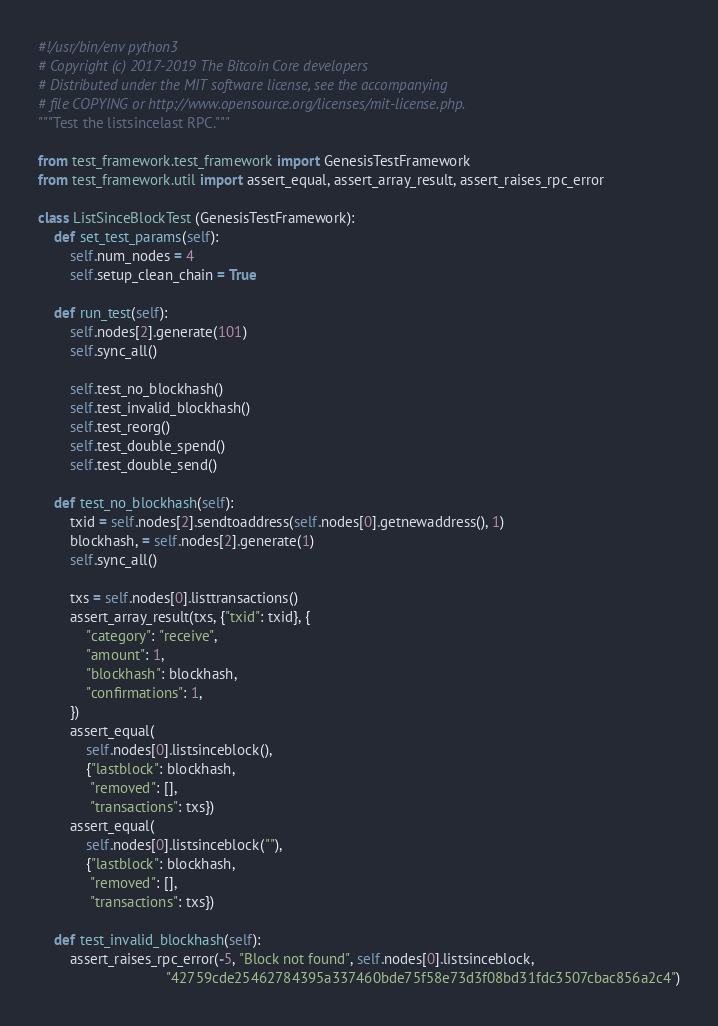<code> <loc_0><loc_0><loc_500><loc_500><_Python_>#!/usr/bin/env python3
# Copyright (c) 2017-2019 The Bitcoin Core developers
# Distributed under the MIT software license, see the accompanying
# file COPYING or http://www.opensource.org/licenses/mit-license.php.
"""Test the listsincelast RPC."""

from test_framework.test_framework import GenesisTestFramework
from test_framework.util import assert_equal, assert_array_result, assert_raises_rpc_error

class ListSinceBlockTest (GenesisTestFramework):
    def set_test_params(self):
        self.num_nodes = 4
        self.setup_clean_chain = True

    def run_test(self):
        self.nodes[2].generate(101)
        self.sync_all()

        self.test_no_blockhash()
        self.test_invalid_blockhash()
        self.test_reorg()
        self.test_double_spend()
        self.test_double_send()

    def test_no_blockhash(self):
        txid = self.nodes[2].sendtoaddress(self.nodes[0].getnewaddress(), 1)
        blockhash, = self.nodes[2].generate(1)
        self.sync_all()

        txs = self.nodes[0].listtransactions()
        assert_array_result(txs, {"txid": txid}, {
            "category": "receive",
            "amount": 1,
            "blockhash": blockhash,
            "confirmations": 1,
        })
        assert_equal(
            self.nodes[0].listsinceblock(),
            {"lastblock": blockhash,
             "removed": [],
             "transactions": txs})
        assert_equal(
            self.nodes[0].listsinceblock(""),
            {"lastblock": blockhash,
             "removed": [],
             "transactions": txs})

    def test_invalid_blockhash(self):
        assert_raises_rpc_error(-5, "Block not found", self.nodes[0].listsinceblock,
                                "42759cde25462784395a337460bde75f58e73d3f08bd31fdc3507cbac856a2c4")</code> 